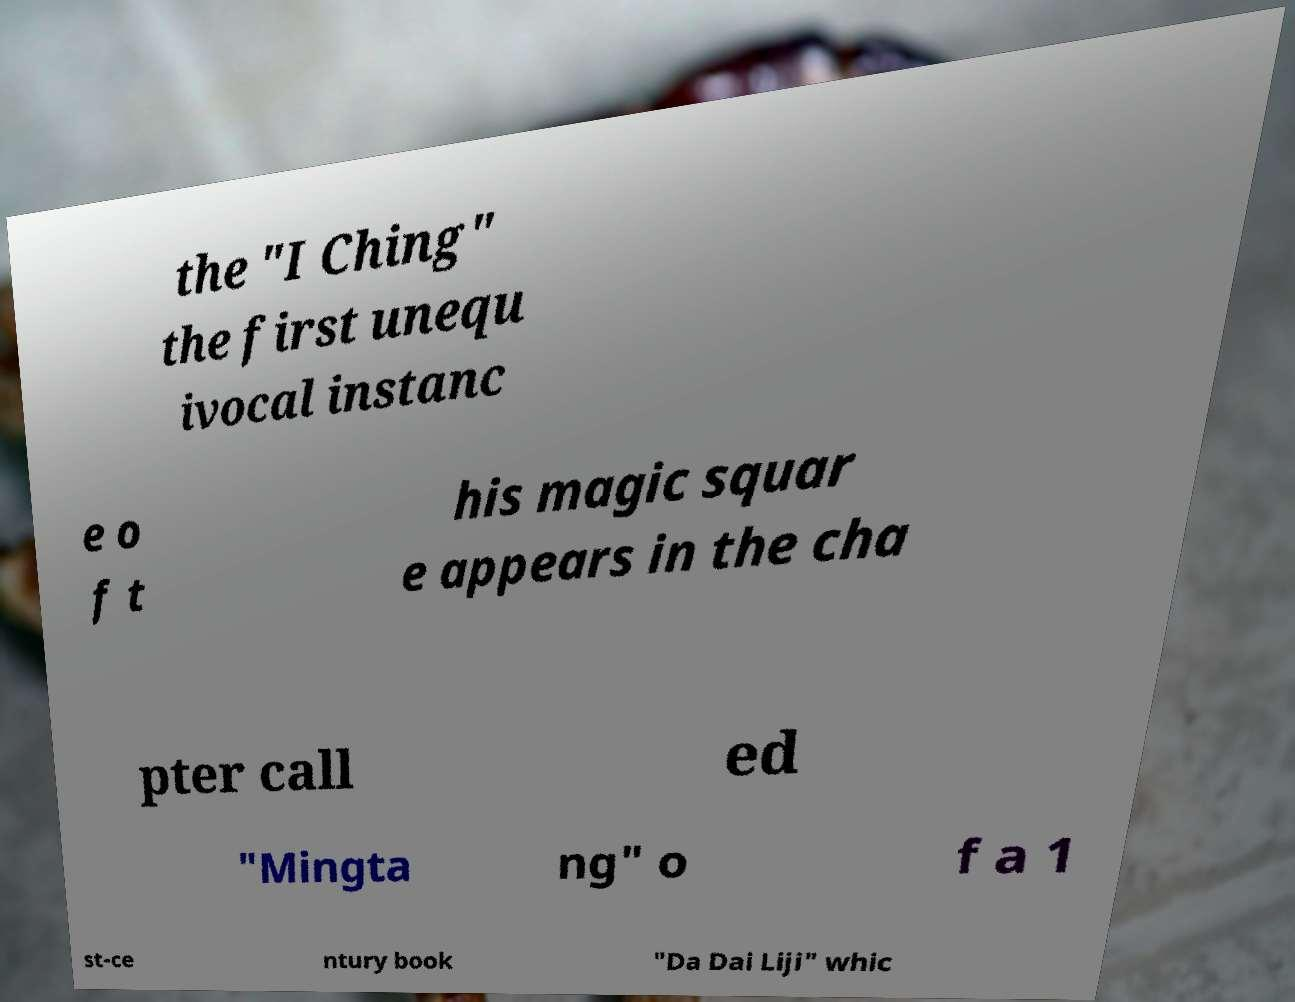For documentation purposes, I need the text within this image transcribed. Could you provide that? the "I Ching" the first unequ ivocal instanc e o f t his magic squar e appears in the cha pter call ed "Mingta ng" o f a 1 st-ce ntury book "Da Dai Liji" whic 